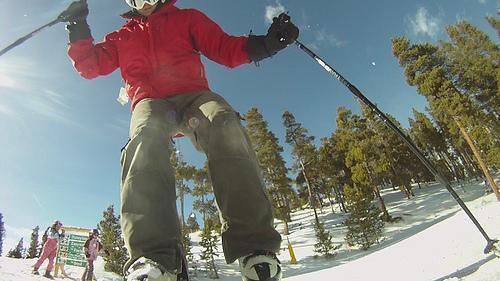Why does the person have poles?
Make your selection from the four choices given to correctly answer the question.
Options: Balance, visibility, fashion, protection. Balance. 